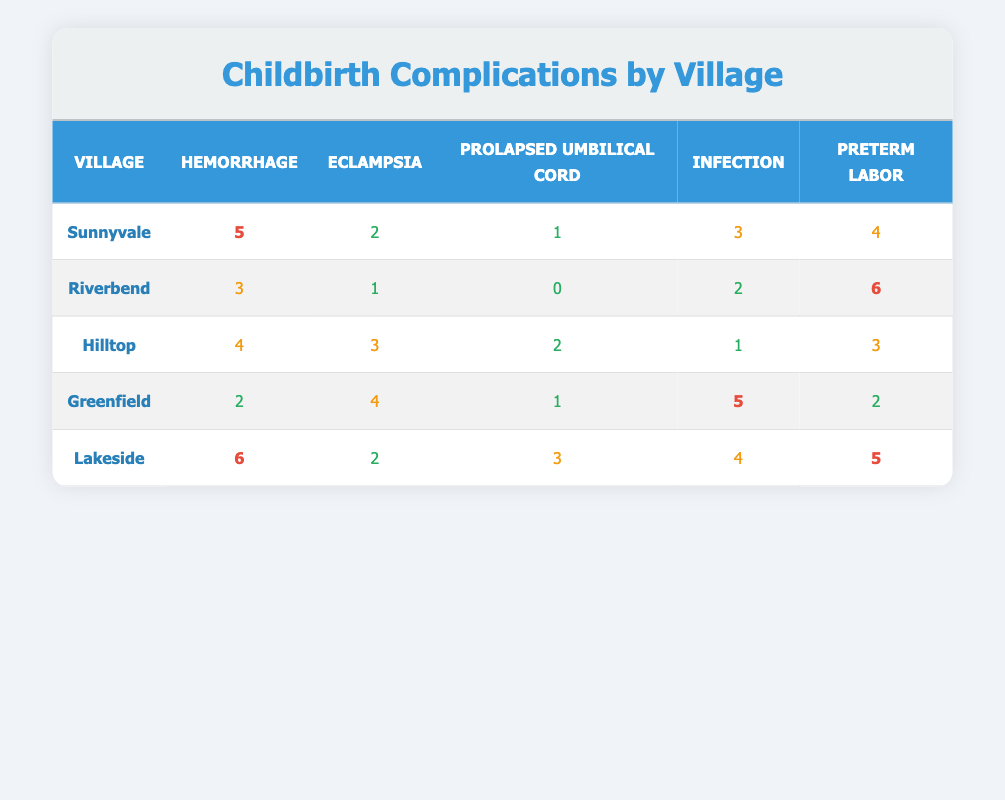What village has the highest number of cases of hemorrhage? To find this, I will look at the "Hemorrhage" column and identify the maximum value. The highest value is 6, which corresponds to Lakeside.
Answer: Lakeside How many cases of eclampsia are there in Greenfield? The "Eclampsia" column for Greenfield shows 4 cases.
Answer: 4 What is the total number of preterm labor cases across all villages? I will sum the "Preterm Labor" values for all villages: 4 (Sunnyvale) + 6 (Riverbend) + 3 (Hilltop) + 2 (Greenfield) + 5 (Lakeside) = 20.
Answer: 20 True or false: Riverbend has more cases of infections than Hilltop does. In Riverbend, there are 2 cases of infections, and in Hilltop, there is 1 case. Since 2 is greater than 1, the statement is true.
Answer: True What is the average number of prolapsed umbilical cord cases across all villages? I will add the values from the "Prolapsed Umbilical Cord" column: 1 (Sunnyvale) + 0 (Riverbend) + 2 (Hilltop) + 1 (Greenfield) + 3 (Lakeside) = 7. There are 5 villages, so the average is 7 divided by 5, which equals 1.4.
Answer: 1.4 Which village has the lowest overall childbirth complications? To determine this, I will calculate the total complications for each village by summing all listed complications. Sunnyvale: 5 + 2 + 1 + 3 + 4 = 15, Riverbend: 3 + 1 + 0 + 2 + 6 = 12, Hilltop: 4 + 3 + 2 + 1 + 3 = 13, Greenfield: 2 + 4 + 1 + 5 + 2 = 14, Lakeside: 6 + 2 + 3 + 4 + 5 = 20. Riverbend has the lowest total of 12.
Answer: Riverbend How many complications did Lakeside have in total? For Lakeside, I will sum the complications: Hemorrhage: 6, Eclampsia: 2, Prolapsed Umbilical Cord: 3, Infection: 4, Preterm Labor: 5. Adding these gives 6 + 2 + 3 + 4 + 5 = 20.
Answer: 20 Is there any village that has no cases of prolapsed umbilical cord? Reviewing the "Prolapsed Umbilical Cord" column, Riverbend shows a count of 0 cases, indicating that it does not have any cases of this complication.
Answer: Yes What village has the highest number of cases of infection? Looking at the "Infection" column, I see that Greenfield has the highest number at 5 cases.
Answer: Greenfield 